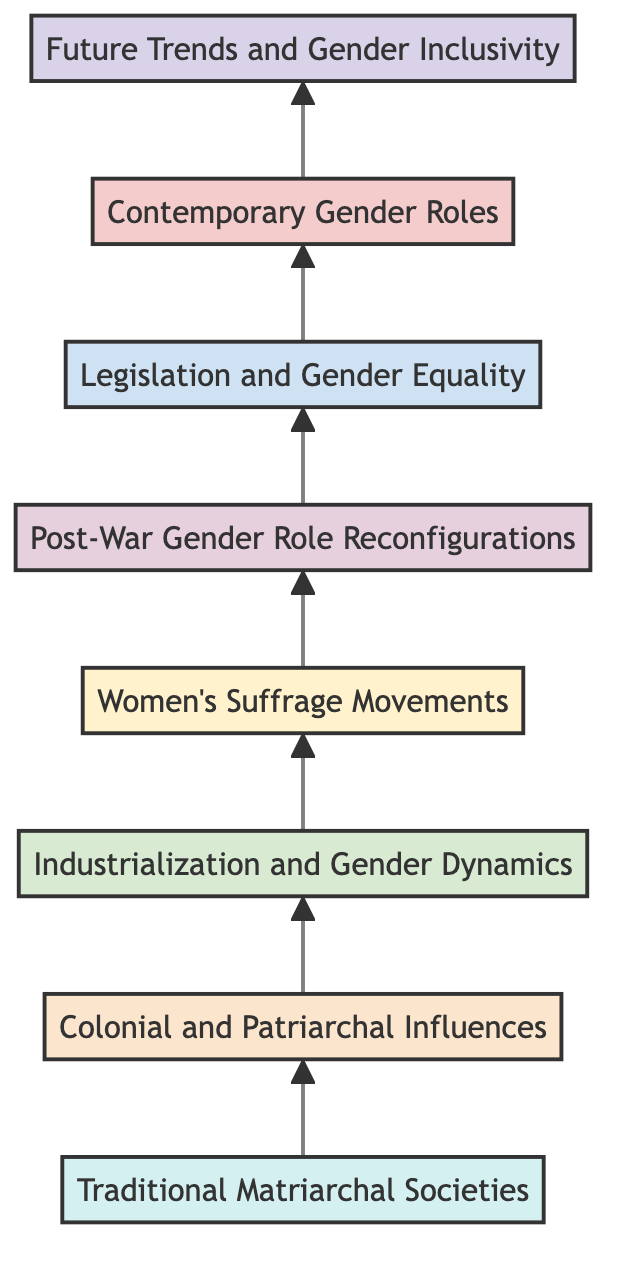What is the highest level in the flow chart? The highest level in the flow chart is represented by node H, which is "Future Trends and Gender Inclusivity." This is the top-most element in the Bottom to Top Flow Chart.
Answer: Future Trends and Gender Inclusivity Which level corresponds to "Women's Suffrage Movements"? In the diagram, "Women's Suffrage Movements" is represented by node D, which is on the fourth level. The flow chart is structured with levels increasing as you move upward.
Answer: 4 How many nodes are in the chart? The flow chart contains a total of 8 nodes, each representing different stages in the development of gender roles, from matriarchal societies to contemporary issues.
Answer: 8 What node follows "Post-War Gender Role Reconfigurations"? Following "Post-War Gender Role Reconfigurations," which is node E, the next node in the upward flow is node F, labeled "Legislation and Gender Equality." The flow indicates a sequential progression.
Answer: Legislation and Gender Equality Which node discusses the impact of colonialism? The node that discusses the impact of colonialism is node B, "Colonial and Patriarchal Influences." This node focuses on how these influences have disrupted traditional structures and affected women's status in society.
Answer: Colonial and Patriarchal Influences Which two nodes are connected directly? The nodes that are directly connected are "Industrialization and Gender Dynamics" (node C) and "Women's Suffrage Movements" (node D). The flow demonstrates a direct relationship from one stage to the next in the evolution of gender roles.
Answer: Industrialization and Gender Dynamics, Women's Suffrage Movements What is the implication of the diagram structure? The structure of the diagram indicates a progression or evolution over time concerning gender roles, where each node builds upon the previous one, culminating in contemporary challenges and future inclusivity.
Answer: Progression of gender roles How does the flow chart represent the transition to contemporary gender roles? The flow chart transitions to contemporary gender roles through nodes G and H, highlighting current trends, legal progress, ongoing issues, and speculative future directions for gender inclusivity.
Answer: Through nodes G and H 